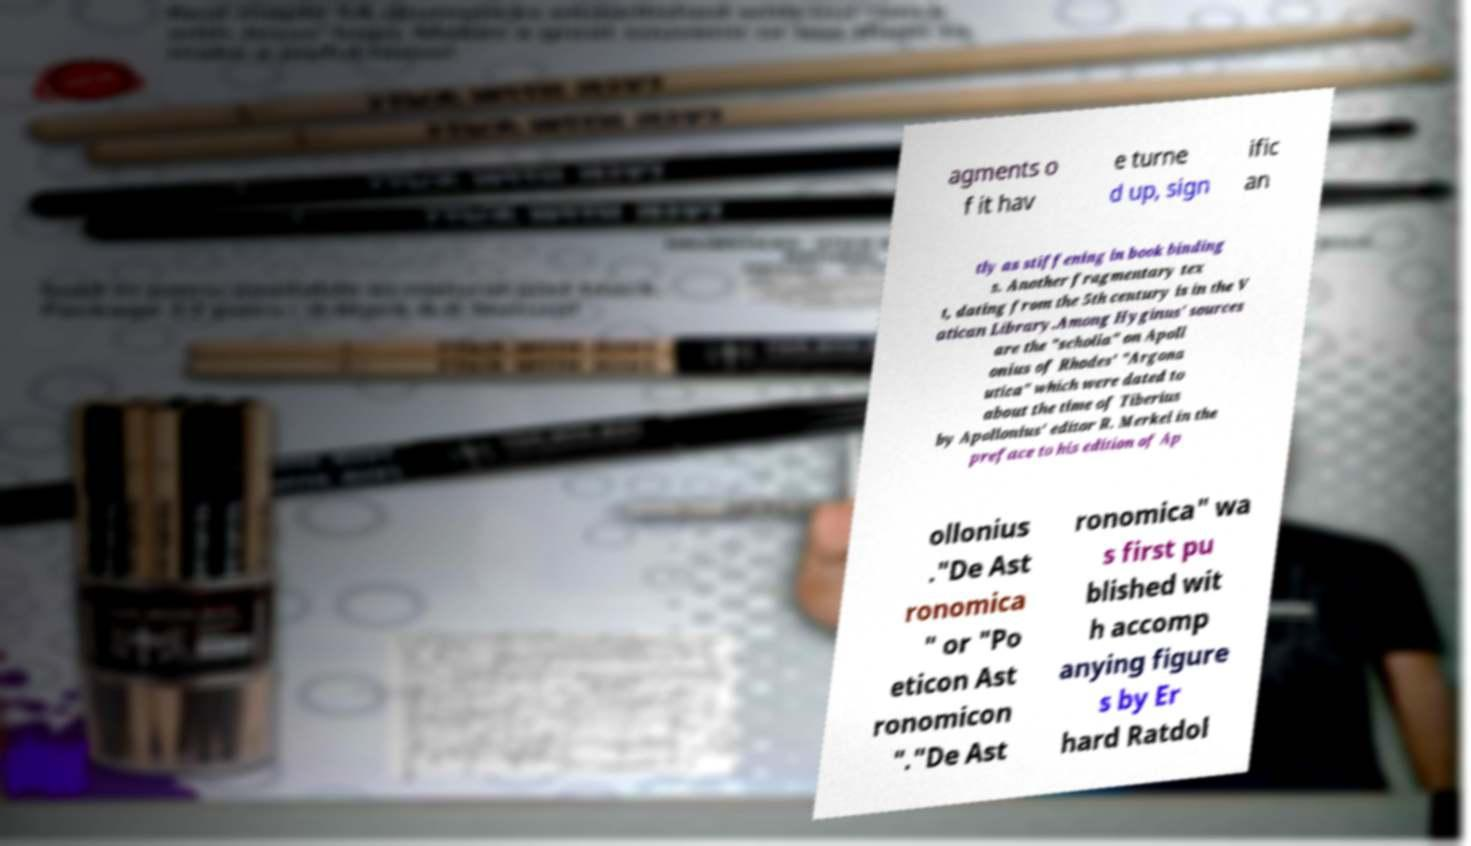Can you read and provide the text displayed in the image?This photo seems to have some interesting text. Can you extract and type it out for me? agments o f it hav e turne d up, sign ific an tly as stiffening in book binding s. Another fragmentary tex t, dating from the 5th century is in the V atican Library.Among Hyginus' sources are the "scholia" on Apoll onius of Rhodes' "Argona utica" which were dated to about the time of Tiberius by Apollonius' editor R. Merkel in the preface to his edition of Ap ollonius ."De Ast ronomica " or "Po eticon Ast ronomicon "."De Ast ronomica" wa s first pu blished wit h accomp anying figure s by Er hard Ratdol 